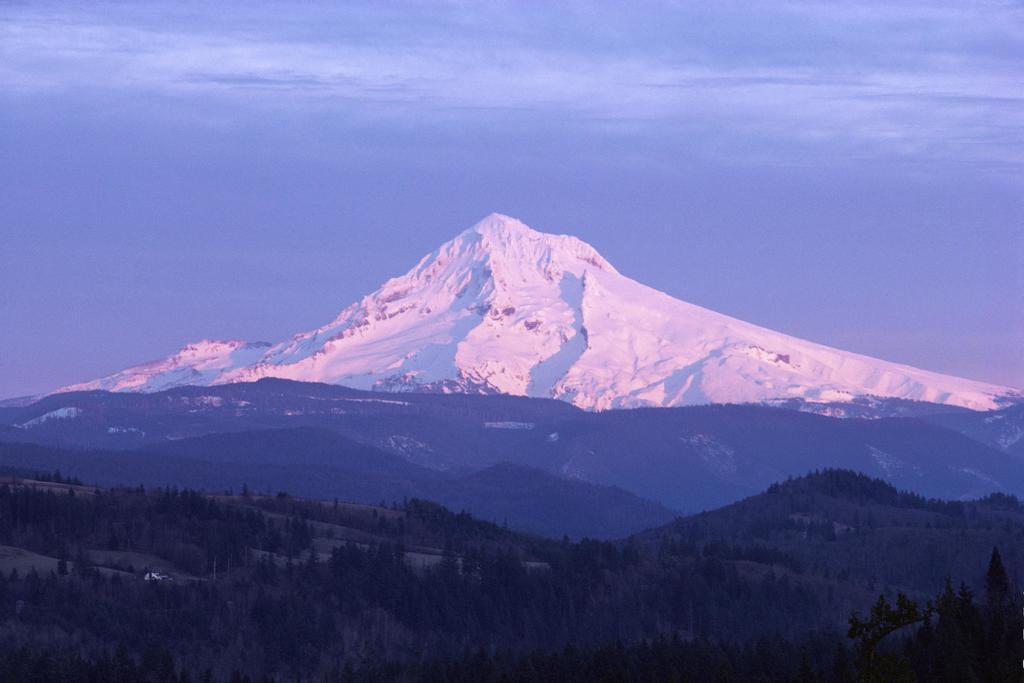Could you give a brief overview of what you see in this image? At the bottom of the image there are hills with grass and trees. Behind them in the background there is a mountain with snow. At the top of the image there is a sky. 